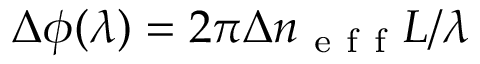<formula> <loc_0><loc_0><loc_500><loc_500>\Delta \phi ( \lambda ) = 2 \pi \Delta n _ { e f f } L / \lambda</formula> 